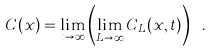Convert formula to latex. <formula><loc_0><loc_0><loc_500><loc_500>C ( x ) = \lim _ { t \to \infty } \left ( \lim _ { L \to \infty } C _ { L } ( x , t ) \right ) \ .</formula> 